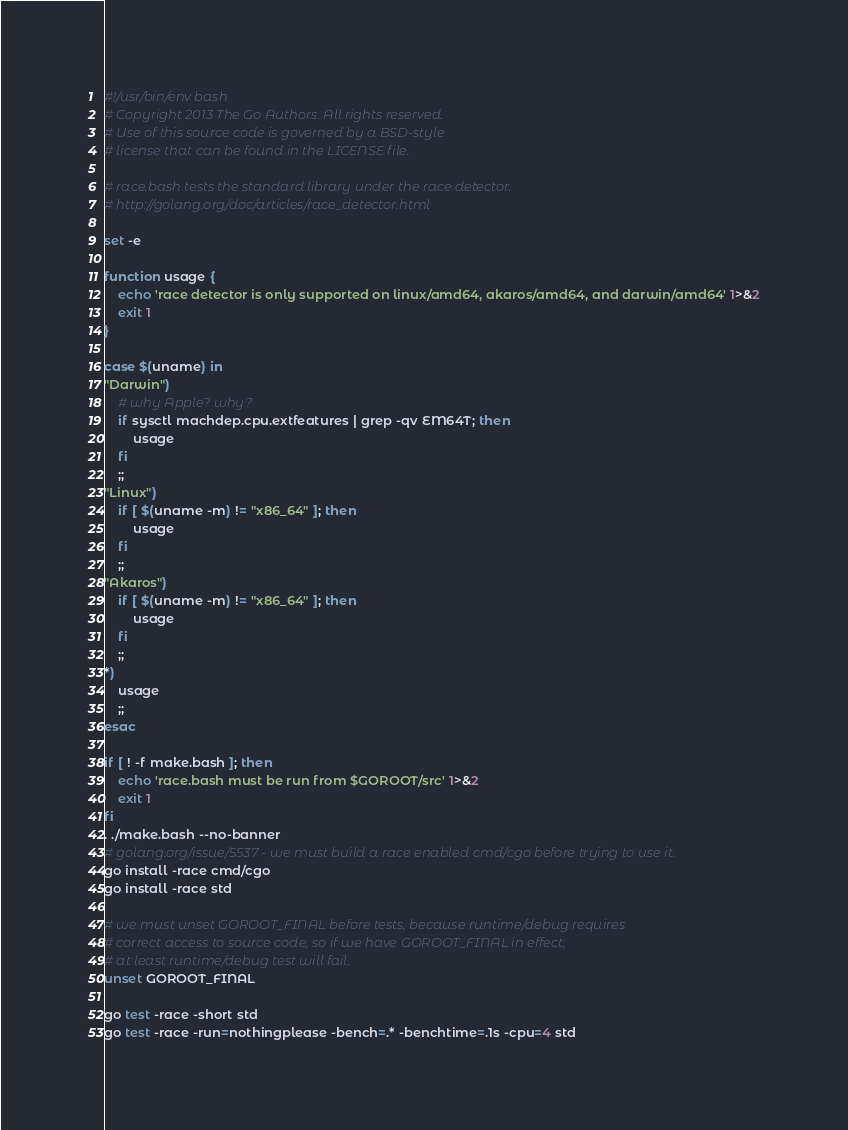Convert code to text. <code><loc_0><loc_0><loc_500><loc_500><_Bash_>#!/usr/bin/env bash
# Copyright 2013 The Go Authors. All rights reserved.
# Use of this source code is governed by a BSD-style
# license that can be found in the LICENSE file.

# race.bash tests the standard library under the race detector.
# http://golang.org/doc/articles/race_detector.html

set -e

function usage {
	echo 'race detector is only supported on linux/amd64, akaros/amd64, and darwin/amd64' 1>&2
	exit 1
}

case $(uname) in
"Darwin")
	# why Apple? why?
	if sysctl machdep.cpu.extfeatures | grep -qv EM64T; then
		usage
	fi 
	;;
"Linux")
	if [ $(uname -m) != "x86_64" ]; then
		usage
	fi
	;;
"Akaros")
	if [ $(uname -m) != "x86_64" ]; then
		usage
	fi
	;;
*)
	usage
	;;
esac

if [ ! -f make.bash ]; then
	echo 'race.bash must be run from $GOROOT/src' 1>&2
	exit 1
fi
. ./make.bash --no-banner
# golang.org/issue/5537 - we must build a race enabled cmd/cgo before trying to use it.
go install -race cmd/cgo
go install -race std

# we must unset GOROOT_FINAL before tests, because runtime/debug requires
# correct access to source code, so if we have GOROOT_FINAL in effect,
# at least runtime/debug test will fail.
unset GOROOT_FINAL

go test -race -short std
go test -race -run=nothingplease -bench=.* -benchtime=.1s -cpu=4 std
</code> 